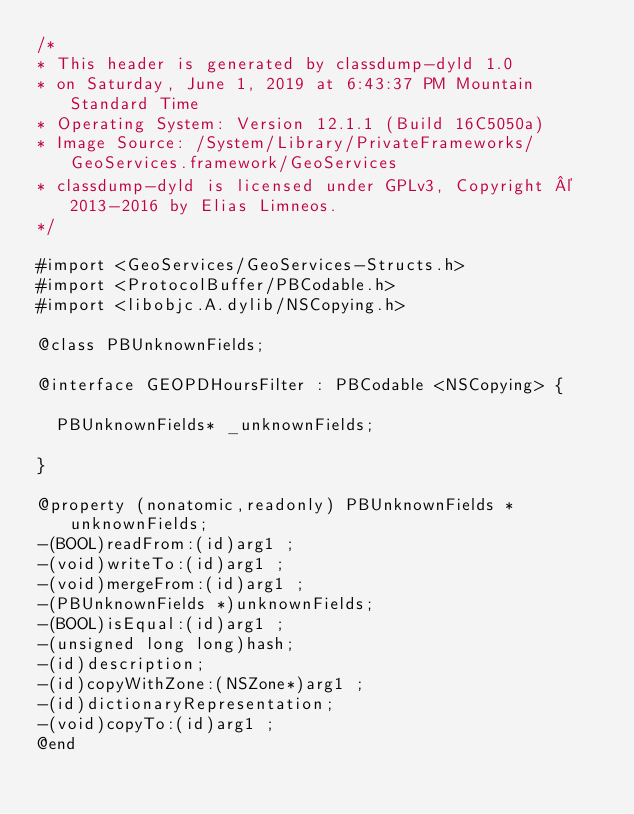<code> <loc_0><loc_0><loc_500><loc_500><_C_>/*
* This header is generated by classdump-dyld 1.0
* on Saturday, June 1, 2019 at 6:43:37 PM Mountain Standard Time
* Operating System: Version 12.1.1 (Build 16C5050a)
* Image Source: /System/Library/PrivateFrameworks/GeoServices.framework/GeoServices
* classdump-dyld is licensed under GPLv3, Copyright © 2013-2016 by Elias Limneos.
*/

#import <GeoServices/GeoServices-Structs.h>
#import <ProtocolBuffer/PBCodable.h>
#import <libobjc.A.dylib/NSCopying.h>

@class PBUnknownFields;

@interface GEOPDHoursFilter : PBCodable <NSCopying> {

	PBUnknownFields* _unknownFields;

}

@property (nonatomic,readonly) PBUnknownFields * unknownFields; 
-(BOOL)readFrom:(id)arg1 ;
-(void)writeTo:(id)arg1 ;
-(void)mergeFrom:(id)arg1 ;
-(PBUnknownFields *)unknownFields;
-(BOOL)isEqual:(id)arg1 ;
-(unsigned long long)hash;
-(id)description;
-(id)copyWithZone:(NSZone*)arg1 ;
-(id)dictionaryRepresentation;
-(void)copyTo:(id)arg1 ;
@end

</code> 